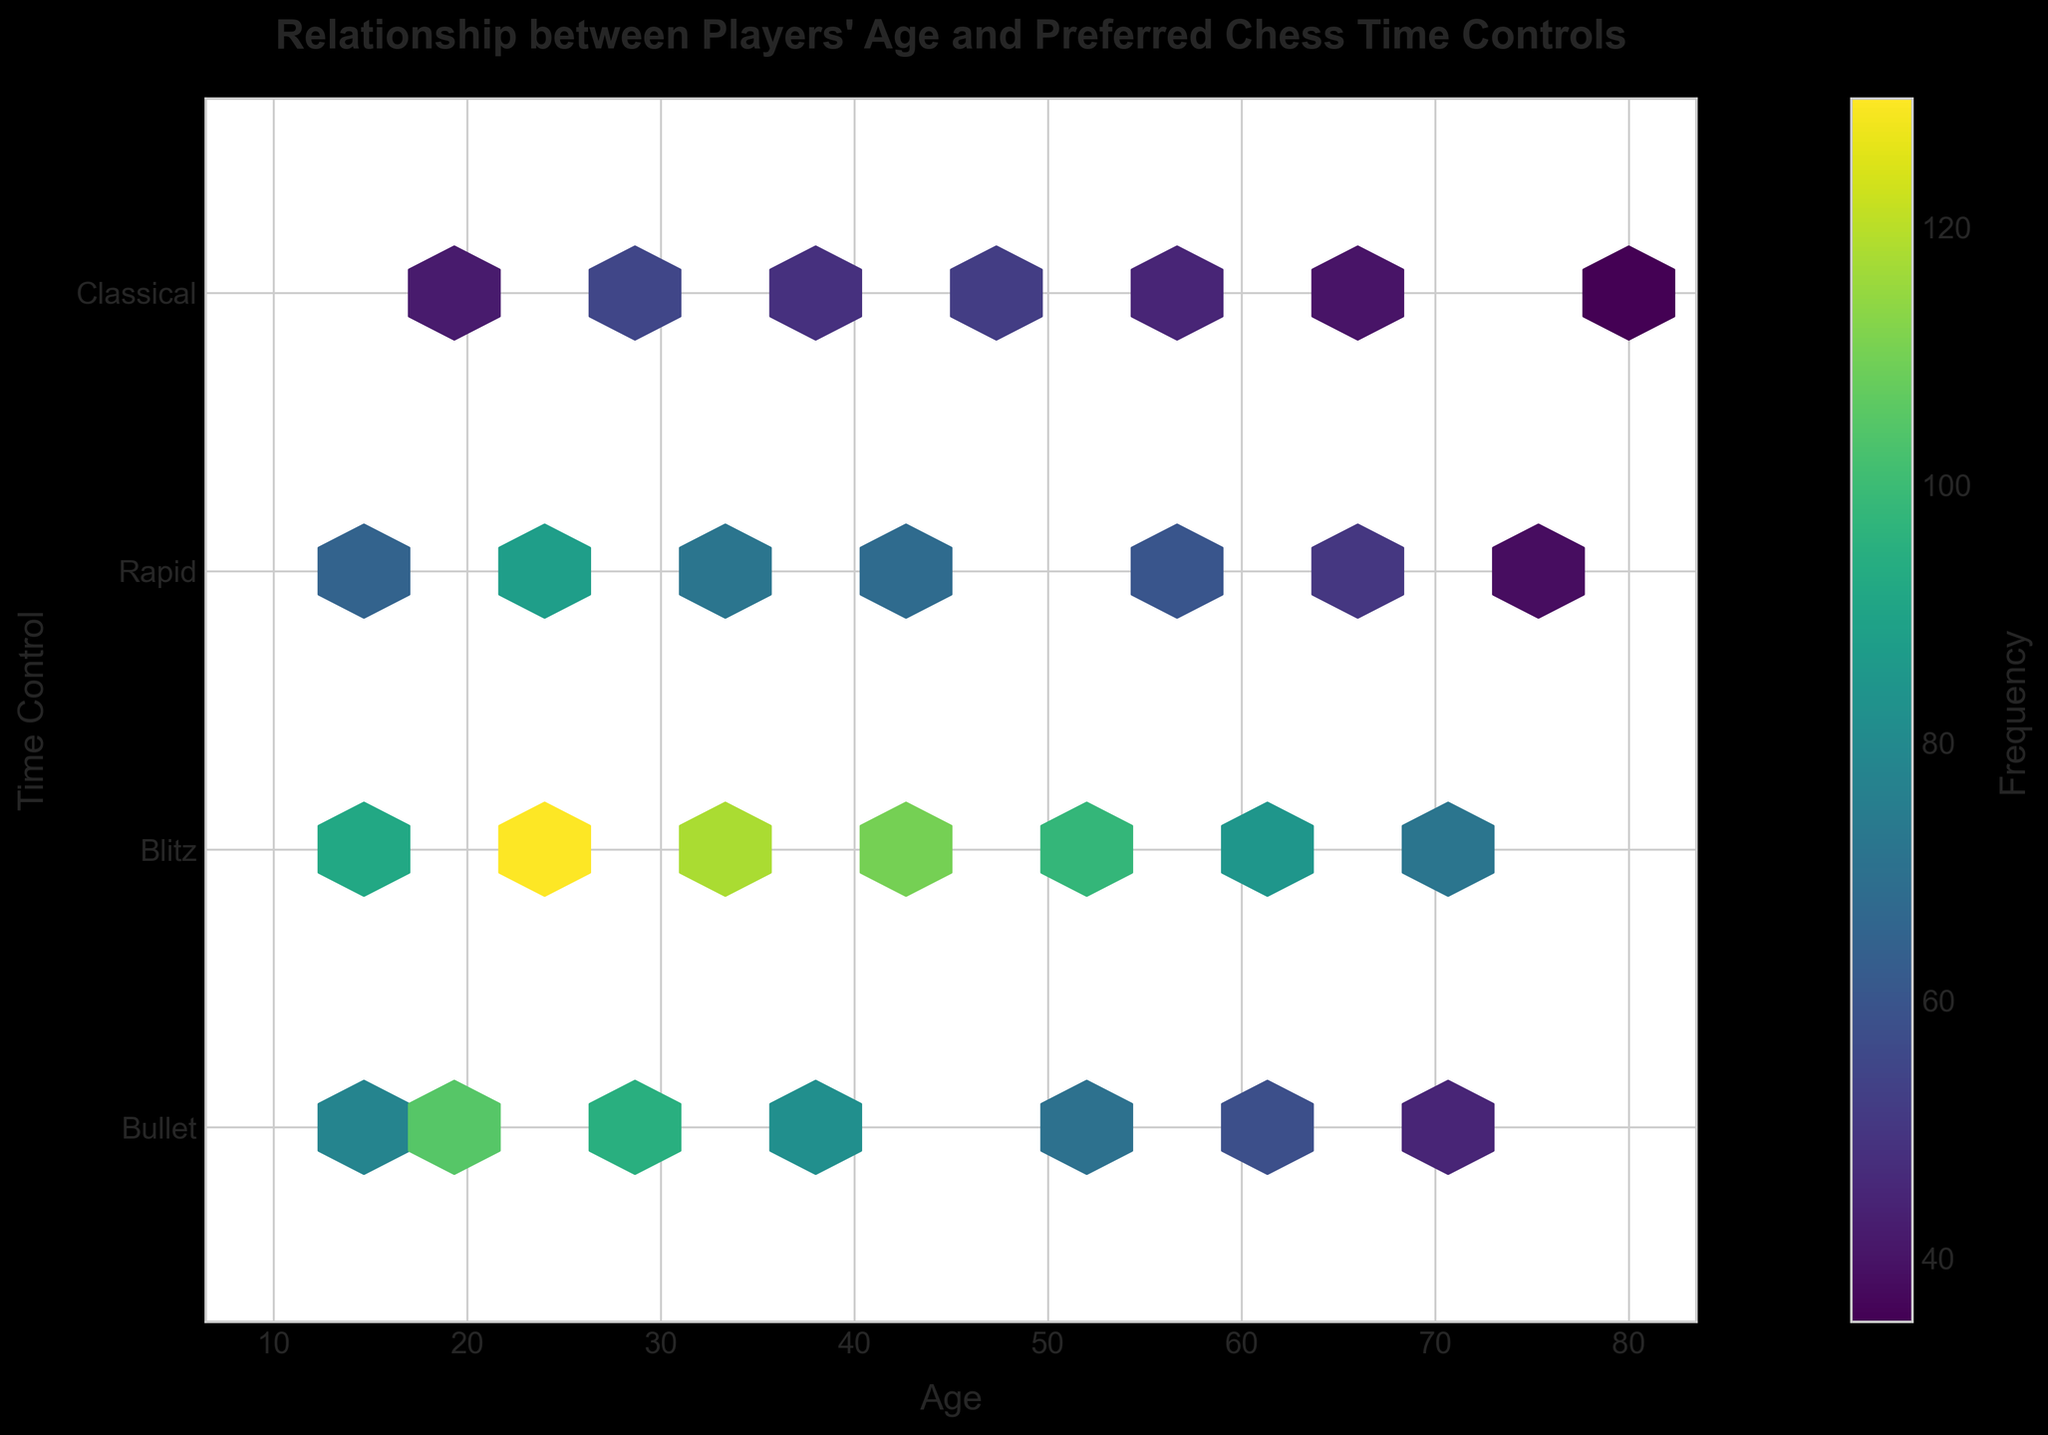what is the title of the plot? The title is usually located at the top of the plot and serves to briefly describe the main insight or observation the plot aims to convey. In this case, the title is: "Relationship between Players' Age and Preferred Chess Time Controls".
Answer: Relationship between Players' Age and Preferred Chess Time Controls What does the color shading represent in the plot? The color shading in a hexbin plot typically encodes the value of a third variable. Here, the hexagons are colored based on the frequency of each age and time control combination. Darker colors indicate higher frequencies.
Answer: Frequency What age group prefers 'Blitz' the most? To determine this, look for the darkest hexagon in the 'Blitz' row. The hexbin plot shows the highest frequency for 'Blitz' appears around age 22.
Answer: 22 Which time control seems to be the least preferred by younger players (age < 20)? Examine the hexagons for ages below 20 in each row. 'Classical' time control has lighter hexagons compared to others, indicating lower frequency.
Answer: Classical What time control shows the highest frequency for players aged 50? Find the darkest hexagon in the column corresponding to age 50. It is in the 'Bullet' row.
Answer: Bullet How does the preference for 'Rapid' time control change with age? Start from the left-most hexagons (younger age) in the 'Rapid' row and move right. The frequency increases slightly around the mid-ages (25-35) and then generally decreases towards older ages.
Answer: Increases, then decreases Compare the frequency of 'Bullet' and 'Classical' time controls for the age group 30-40. Identify the color intensity of hexagons in the 'Bullet' and 'Classical' rows for ages 30, 32, 35, and 38. 'Bullet' has generally darker hexagons in this age range, indicating higher frequency compared to 'Classical'.
Answer: Bullet Which time control has a noticeable peak in frequency at age 72? Check the hexagons in the row corresponding to age 72 across all time controls. 'Blitz' has a darker hexagon, indicating a peak.
Answer: Blitz What is the median age of players who prefer 'Rapid' time control? Locate the row for 'Rapid' and find the median age. The distribution of frequencies suggests a concentration around age 35, indicating the median.
Answer: 35 Is there any age group that shows a significant preference for 'Classical' chess? Check for noticeably darker hexagons in the 'Classical' row. There is no age group with significantly darker hexagons compared to other time controls, suggesting no strong preference for 'Classical' at any specific age.
Answer: No 